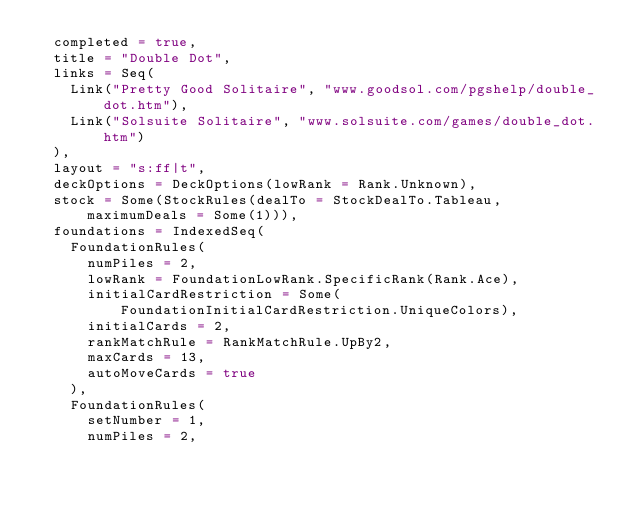Convert code to text. <code><loc_0><loc_0><loc_500><loc_500><_Scala_>  completed = true,
  title = "Double Dot",
  links = Seq(
    Link("Pretty Good Solitaire", "www.goodsol.com/pgshelp/double_dot.htm"),
    Link("Solsuite Solitaire", "www.solsuite.com/games/double_dot.htm")
  ),
  layout = "s:ff|t",
  deckOptions = DeckOptions(lowRank = Rank.Unknown),
  stock = Some(StockRules(dealTo = StockDealTo.Tableau, maximumDeals = Some(1))),
  foundations = IndexedSeq(
    FoundationRules(
      numPiles = 2,
      lowRank = FoundationLowRank.SpecificRank(Rank.Ace),
      initialCardRestriction = Some(FoundationInitialCardRestriction.UniqueColors),
      initialCards = 2,
      rankMatchRule = RankMatchRule.UpBy2,
      maxCards = 13,
      autoMoveCards = true
    ),
    FoundationRules(
      setNumber = 1,
      numPiles = 2,</code> 